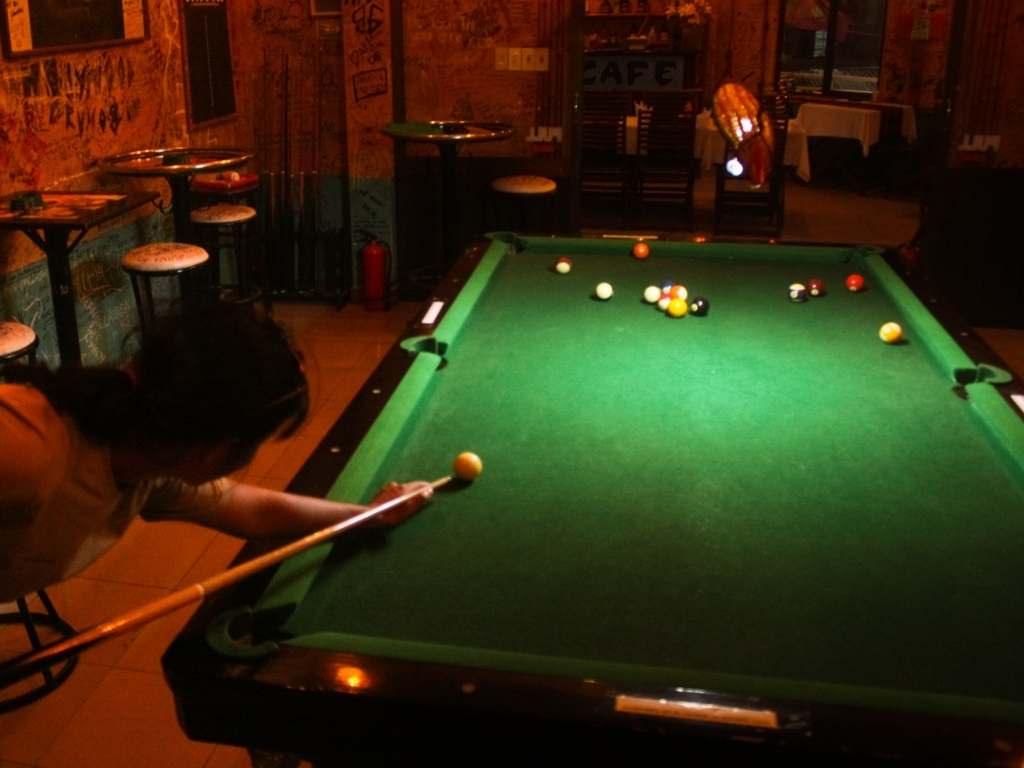Are there any quality issues with this image? The image exhibits a few quality issues such as noticeable motion blur, particularly around the person playing pool, and low lighting conditions that could result in a lack of sharpness and detail. The overall composition might also benefit from adjustments to framing to better capture the action and surroundings. 